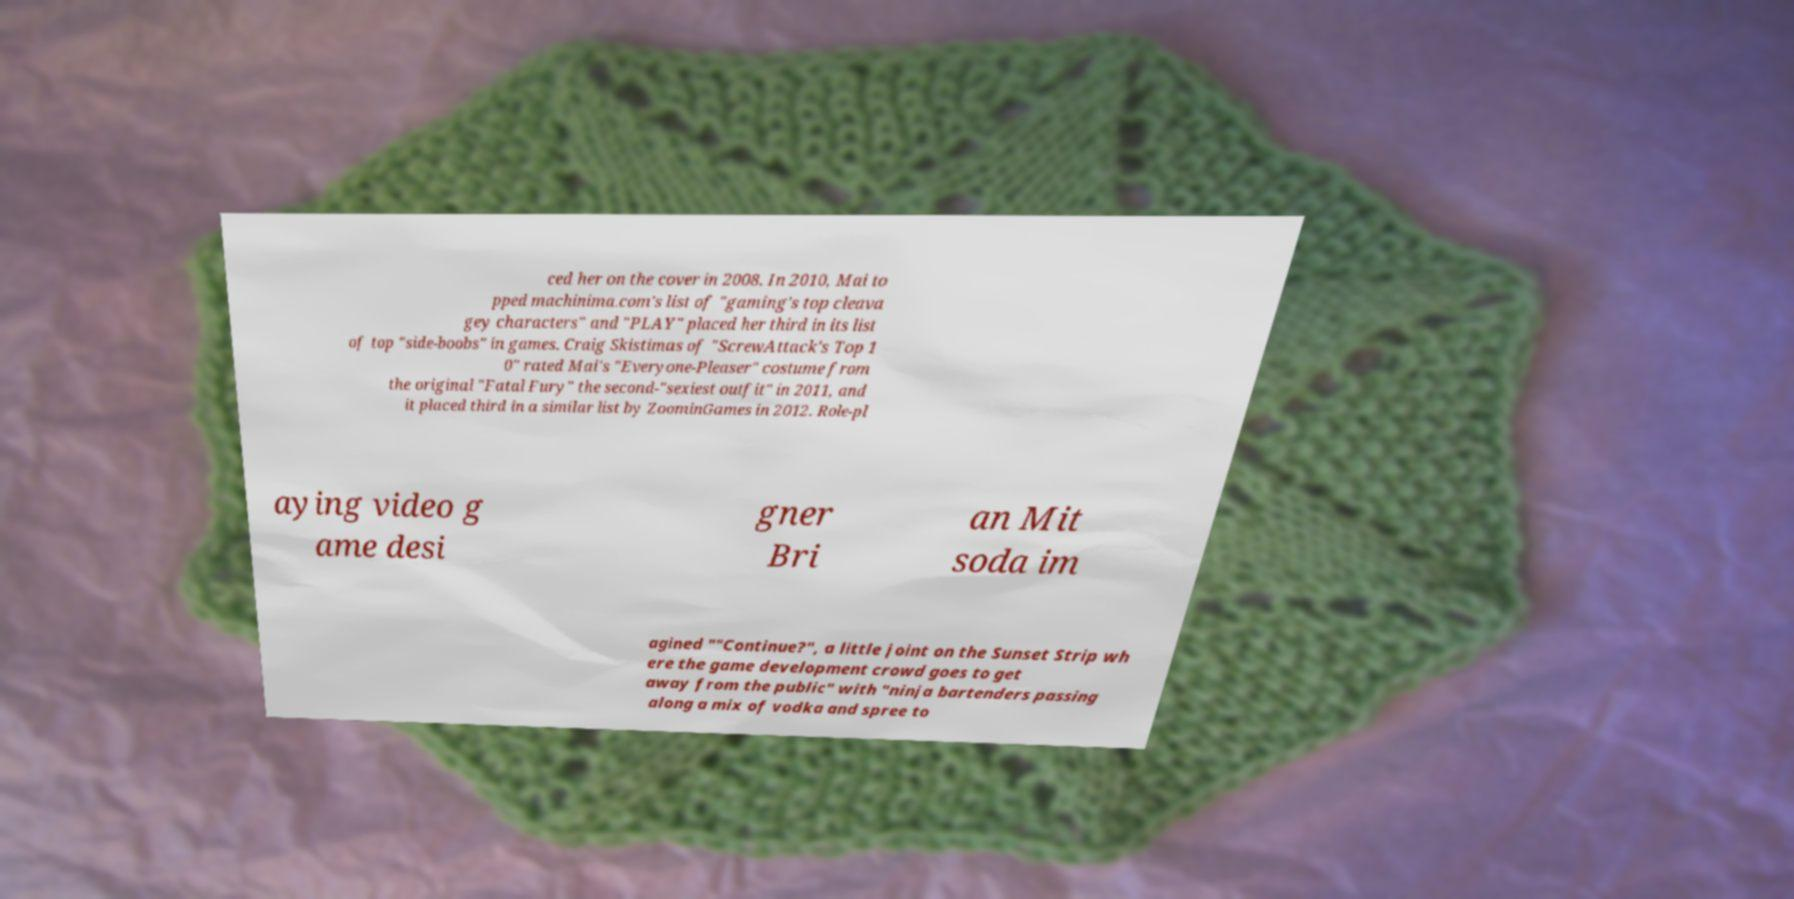There's text embedded in this image that I need extracted. Can you transcribe it verbatim? ced her on the cover in 2008. In 2010, Mai to pped machinima.com's list of "gaming's top cleava gey characters" and "PLAY" placed her third in its list of top "side-boobs" in games. Craig Skistimas of "ScrewAttack's Top 1 0" rated Mai's "Everyone-Pleaser" costume from the original "Fatal Fury" the second-"sexiest outfit" in 2011, and it placed third in a similar list by ZoominGames in 2012. Role-pl aying video g ame desi gner Bri an Mit soda im agined ""Continue?", a little joint on the Sunset Strip wh ere the game development crowd goes to get away from the public" with "ninja bartenders passing along a mix of vodka and spree to 